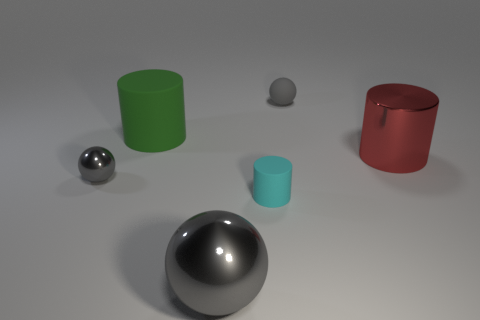Is the number of tiny cyan rubber cylinders that are in front of the large green cylinder greater than the number of large red metal cylinders that are in front of the metallic cylinder?
Your answer should be compact. Yes. What shape is the large matte thing?
Offer a very short reply. Cylinder. Are the tiny sphere in front of the large green matte thing and the gray ball in front of the tiny gray metal ball made of the same material?
Offer a terse response. Yes. There is a large metallic object on the right side of the big gray thing; what is its shape?
Your answer should be very brief. Cylinder. There is a red thing that is the same shape as the cyan matte thing; what size is it?
Offer a terse response. Large. Is the color of the big matte object the same as the large metallic sphere?
Make the answer very short. No. Are there any other things that have the same shape as the big matte thing?
Your answer should be compact. Yes. Is there a large gray sphere to the left of the sphere in front of the small cylinder?
Ensure brevity in your answer.  No. There is a big thing that is the same shape as the tiny gray rubber thing; what color is it?
Keep it short and to the point. Gray. What number of matte things are the same color as the rubber ball?
Give a very brief answer. 0. 